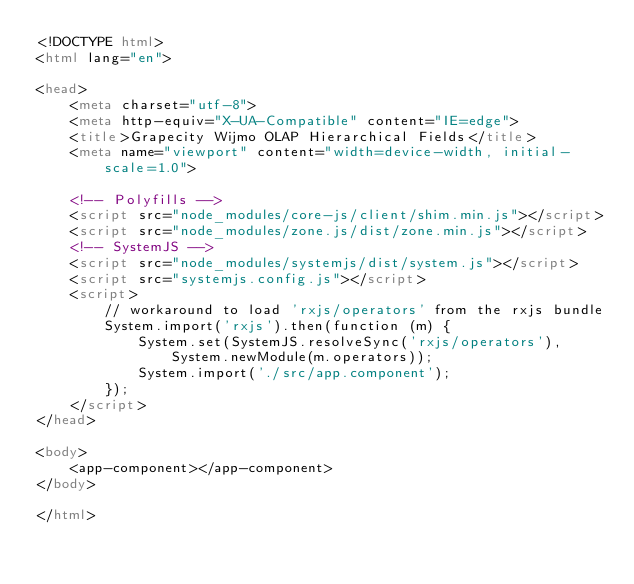Convert code to text. <code><loc_0><loc_0><loc_500><loc_500><_HTML_><!DOCTYPE html>
<html lang="en">

<head>
    <meta charset="utf-8">
    <meta http-equiv="X-UA-Compatible" content="IE=edge">
    <title>Grapecity Wijmo OLAP Hierarchical Fields</title>
    <meta name="viewport" content="width=device-width, initial-scale=1.0">

    <!-- Polyfills -->
    <script src="node_modules/core-js/client/shim.min.js"></script>
    <script src="node_modules/zone.js/dist/zone.min.js"></script>
    <!-- SystemJS -->
    <script src="node_modules/systemjs/dist/system.js"></script>
    <script src="systemjs.config.js"></script>
    <script>
        // workaround to load 'rxjs/operators' from the rxjs bundle
        System.import('rxjs').then(function (m) {
            System.set(SystemJS.resolveSync('rxjs/operators'), System.newModule(m.operators));
            System.import('./src/app.component');
        });
    </script>
</head>

<body>
    <app-component></app-component>
</body>

</html></code> 